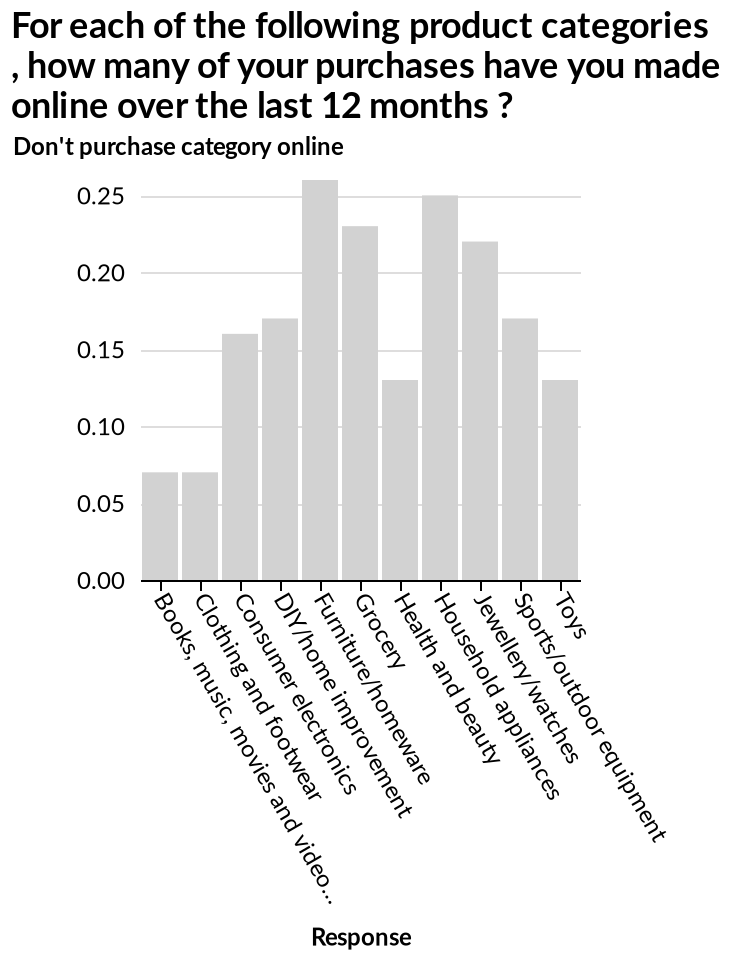<image>
What does the bar chart represent? The bar chart represents the number of online purchases made over the last 12 months for each product category, ranging from Books, music, movies and video games to Toys. What percentage of online purchases were for furniture and homeware in the past year?  0.25. What is the maximum value on the y-axis of the bar chart? The maximum value on the y-axis of the bar chart is 0.25. please describe the details of the chart Here a bar chart is labeled For each of the following product categories , how many of your purchases have you made online over the last 12 months ?. A categorical scale from Books, music, movies and video games to Toys can be seen on the x-axis, marked Response. There is a linear scale with a minimum of 0.00 and a maximum of 0.25 on the y-axis, labeled Don't purchase category online. What was the most popular item to purchase online over the last 12 months?  Furniture and homeware. 